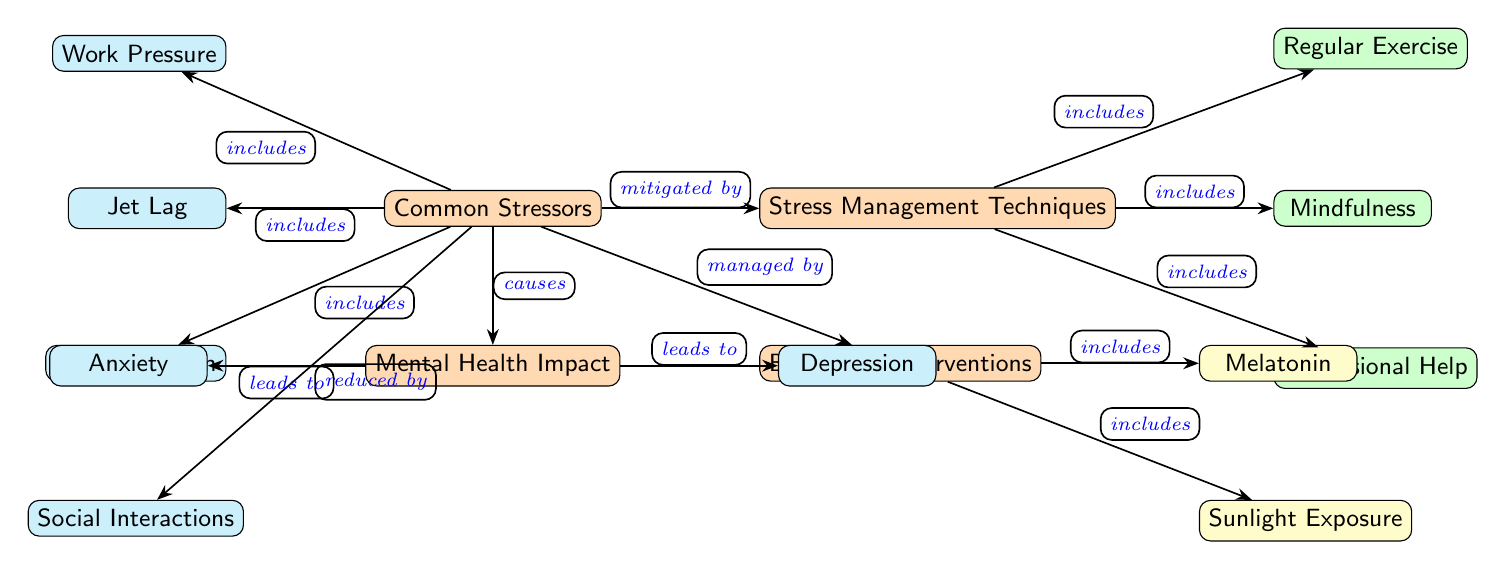What are the common stressors listed in the diagram? The diagram indicates three common stressors: Work Pressure, Jet Lag, and Social Isolation. These nodes are directly connected to the "Common Stressors" node.
Answer: Work Pressure, Jet Lag, Social Isolation How many stress management techniques are mentioned? The diagram shows three stress management techniques: Regular Exercise, Mindfulness, and Professional Help. These nodes are linked to the "Stress Management Techniques" node.
Answer: 3 What does social isolation lead to in terms of mental health? According to the diagram, Social Isolation leads to the "Mental Health Impact," which is depicted as either Anxiety or Depression.
Answer: Anxiety, Depression Which biomedical intervention is associated with sunlight exposure? The diagram explicitly connects Sunlight Exposure under the "Biomedical Interventions" node. This indicates that it is one of the methods under biomedical management for stress.
Answer: Sunlight Exposure What relationships are shown between stressors and mental health? The diagram reveals that Common Stressors are linked to Mental Health Impact, indicating that stressors include Work Pressure, Jet Lag, and Social Isolation as causes for mental health issues.
Answer: Causes Which technique in stress management includes professional help? The diagram directly states that Professional Help is one of the stress management techniques, linking it to the "Stress Management Techniques" node.
Answer: Professional Help What leads from mental health impact to anxiety? The connection specified in the diagram indicates that mental health impact leads to anxiety as one of the direct consequences.
Answer: Leads to How many biomedical interventions are specified in the diagram? There are two biomedical interventions listed in the diagram: Melatonin and Sunlight Exposure, both connected under the "Biomedical Interventions" node.
Answer: 2 